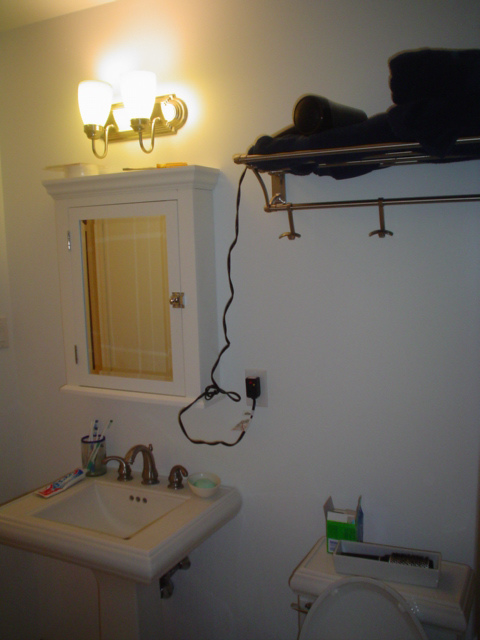<image>What color is the tape in the bathroom? There is no tape in the bathroom. What color is the tape in the bathroom? There is no tape in the bathroom. 